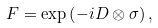<formula> <loc_0><loc_0><loc_500><loc_500>\ F = \exp \left ( - i D \otimes \sigma \right ) ,</formula> 